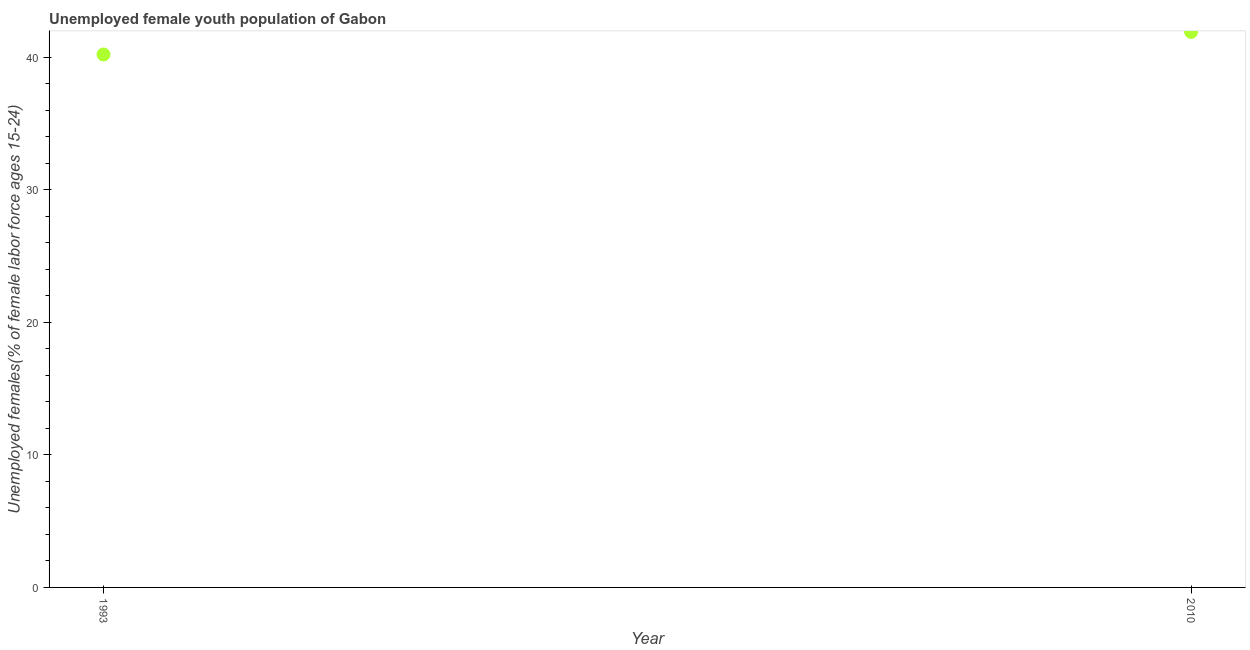What is the unemployed female youth in 1993?
Your answer should be compact. 40.2. Across all years, what is the maximum unemployed female youth?
Offer a very short reply. 41.9. Across all years, what is the minimum unemployed female youth?
Your answer should be very brief. 40.2. In which year was the unemployed female youth maximum?
Offer a very short reply. 2010. What is the sum of the unemployed female youth?
Your answer should be compact. 82.1. What is the difference between the unemployed female youth in 1993 and 2010?
Ensure brevity in your answer.  -1.7. What is the average unemployed female youth per year?
Your answer should be compact. 41.05. What is the median unemployed female youth?
Make the answer very short. 41.05. In how many years, is the unemployed female youth greater than 32 %?
Give a very brief answer. 2. What is the ratio of the unemployed female youth in 1993 to that in 2010?
Your answer should be compact. 0.96. In how many years, is the unemployed female youth greater than the average unemployed female youth taken over all years?
Provide a succinct answer. 1. How many dotlines are there?
Offer a very short reply. 1. How many years are there in the graph?
Your answer should be compact. 2. What is the difference between two consecutive major ticks on the Y-axis?
Make the answer very short. 10. What is the title of the graph?
Make the answer very short. Unemployed female youth population of Gabon. What is the label or title of the X-axis?
Give a very brief answer. Year. What is the label or title of the Y-axis?
Offer a terse response. Unemployed females(% of female labor force ages 15-24). What is the Unemployed females(% of female labor force ages 15-24) in 1993?
Keep it short and to the point. 40.2. What is the Unemployed females(% of female labor force ages 15-24) in 2010?
Ensure brevity in your answer.  41.9. What is the ratio of the Unemployed females(% of female labor force ages 15-24) in 1993 to that in 2010?
Provide a short and direct response. 0.96. 